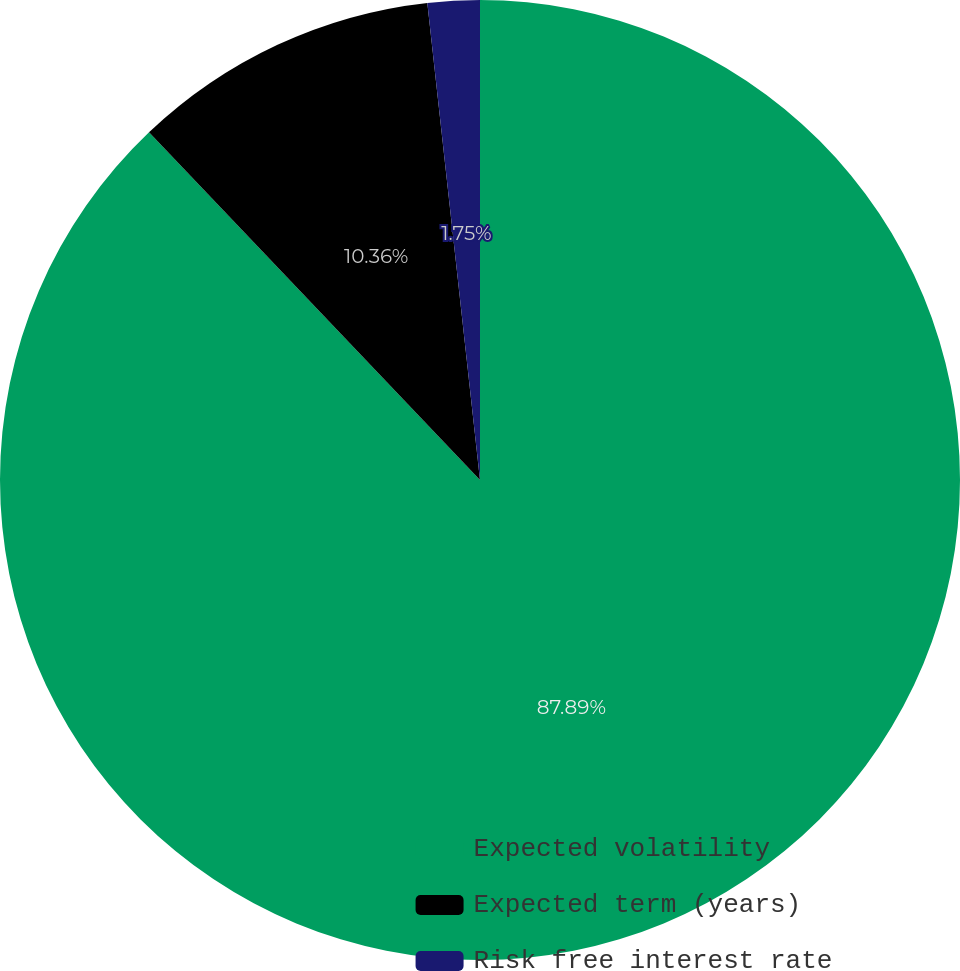Convert chart to OTSL. <chart><loc_0><loc_0><loc_500><loc_500><pie_chart><fcel>Expected volatility<fcel>Expected term (years)<fcel>Risk free interest rate<nl><fcel>87.89%<fcel>10.36%<fcel>1.75%<nl></chart> 